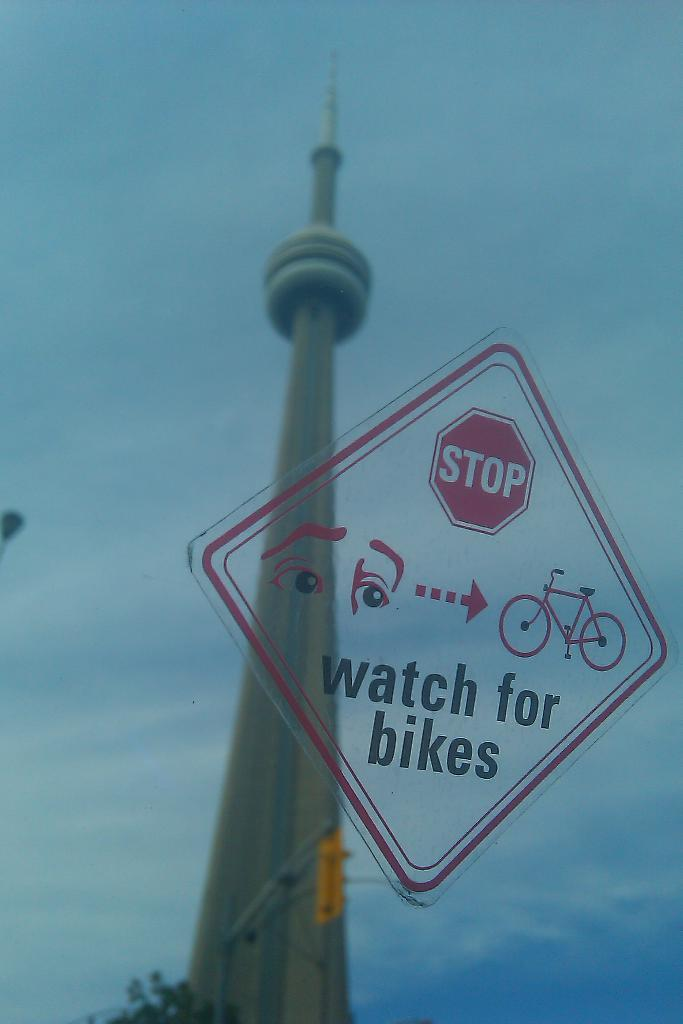Provide a one-sentence caption for the provided image. A stop sign warning people to watch for bikes printed on a piece of glass. A monument can be seen in the reflection. 